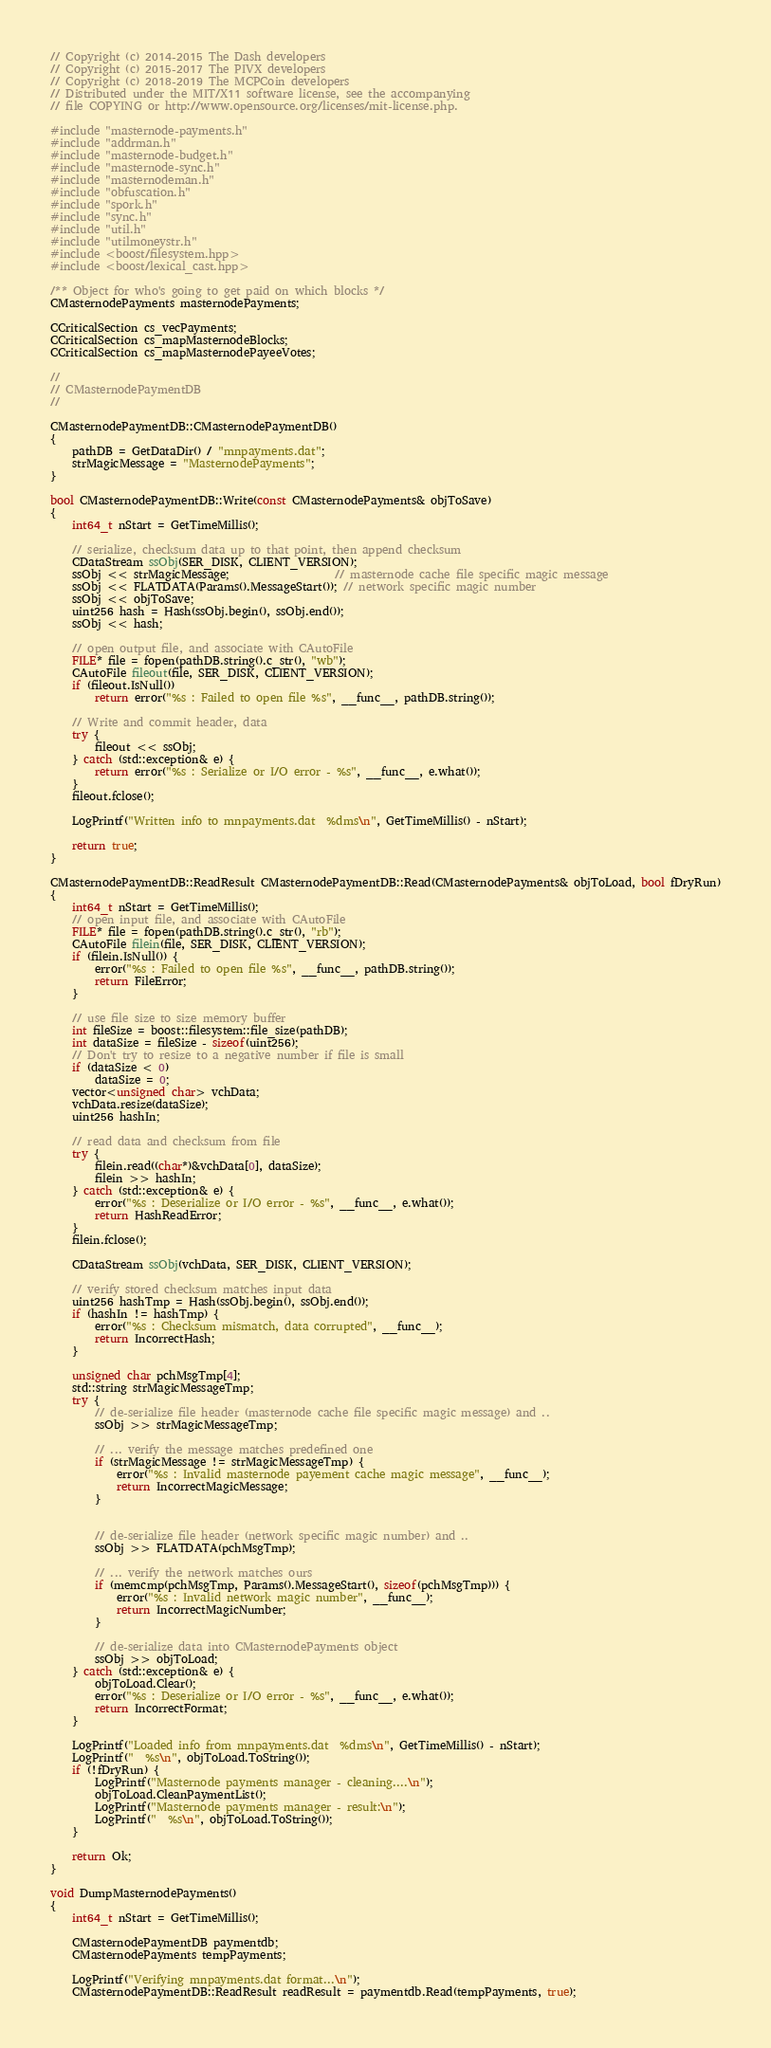<code> <loc_0><loc_0><loc_500><loc_500><_C++_>// Copyright (c) 2014-2015 The Dash developers
// Copyright (c) 2015-2017 The PIVX developers
// Copyright (c) 2018-2019 The MCPCoin developers
// Distributed under the MIT/X11 software license, see the accompanying
// file COPYING or http://www.opensource.org/licenses/mit-license.php.

#include "masternode-payments.h"
#include "addrman.h"
#include "masternode-budget.h"
#include "masternode-sync.h"
#include "masternodeman.h"
#include "obfuscation.h"
#include "spork.h"
#include "sync.h"
#include "util.h"
#include "utilmoneystr.h"
#include <boost/filesystem.hpp>
#include <boost/lexical_cast.hpp>

/** Object for who's going to get paid on which blocks */
CMasternodePayments masternodePayments;

CCriticalSection cs_vecPayments;
CCriticalSection cs_mapMasternodeBlocks;
CCriticalSection cs_mapMasternodePayeeVotes;

//
// CMasternodePaymentDB
//

CMasternodePaymentDB::CMasternodePaymentDB()
{
    pathDB = GetDataDir() / "mnpayments.dat";
    strMagicMessage = "MasternodePayments";
}

bool CMasternodePaymentDB::Write(const CMasternodePayments& objToSave)
{
    int64_t nStart = GetTimeMillis();

    // serialize, checksum data up to that point, then append checksum
    CDataStream ssObj(SER_DISK, CLIENT_VERSION);
    ssObj << strMagicMessage;                   // masternode cache file specific magic message
    ssObj << FLATDATA(Params().MessageStart()); // network specific magic number
    ssObj << objToSave;
    uint256 hash = Hash(ssObj.begin(), ssObj.end());
    ssObj << hash;

    // open output file, and associate with CAutoFile
    FILE* file = fopen(pathDB.string().c_str(), "wb");
    CAutoFile fileout(file, SER_DISK, CLIENT_VERSION);
    if (fileout.IsNull())
        return error("%s : Failed to open file %s", __func__, pathDB.string());

    // Write and commit header, data
    try {
        fileout << ssObj;
    } catch (std::exception& e) {
        return error("%s : Serialize or I/O error - %s", __func__, e.what());
    }
    fileout.fclose();

    LogPrintf("Written info to mnpayments.dat  %dms\n", GetTimeMillis() - nStart);

    return true;
}

CMasternodePaymentDB::ReadResult CMasternodePaymentDB::Read(CMasternodePayments& objToLoad, bool fDryRun)
{
    int64_t nStart = GetTimeMillis();
    // open input file, and associate with CAutoFile
    FILE* file = fopen(pathDB.string().c_str(), "rb");
    CAutoFile filein(file, SER_DISK, CLIENT_VERSION);
    if (filein.IsNull()) {
        error("%s : Failed to open file %s", __func__, pathDB.string());
        return FileError;
    }

    // use file size to size memory buffer
    int fileSize = boost::filesystem::file_size(pathDB);
    int dataSize = fileSize - sizeof(uint256);
    // Don't try to resize to a negative number if file is small
    if (dataSize < 0)
        dataSize = 0;
    vector<unsigned char> vchData;
    vchData.resize(dataSize);
    uint256 hashIn;

    // read data and checksum from file
    try {
        filein.read((char*)&vchData[0], dataSize);
        filein >> hashIn;
    } catch (std::exception& e) {
        error("%s : Deserialize or I/O error - %s", __func__, e.what());
        return HashReadError;
    }
    filein.fclose();

    CDataStream ssObj(vchData, SER_DISK, CLIENT_VERSION);

    // verify stored checksum matches input data
    uint256 hashTmp = Hash(ssObj.begin(), ssObj.end());
    if (hashIn != hashTmp) {
        error("%s : Checksum mismatch, data corrupted", __func__);
        return IncorrectHash;
    }

    unsigned char pchMsgTmp[4];
    std::string strMagicMessageTmp;
    try {
        // de-serialize file header (masternode cache file specific magic message) and ..
        ssObj >> strMagicMessageTmp;

        // ... verify the message matches predefined one
        if (strMagicMessage != strMagicMessageTmp) {
            error("%s : Invalid masternode payement cache magic message", __func__);
            return IncorrectMagicMessage;
        }


        // de-serialize file header (network specific magic number) and ..
        ssObj >> FLATDATA(pchMsgTmp);

        // ... verify the network matches ours
        if (memcmp(pchMsgTmp, Params().MessageStart(), sizeof(pchMsgTmp))) {
            error("%s : Invalid network magic number", __func__);
            return IncorrectMagicNumber;
        }

        // de-serialize data into CMasternodePayments object
        ssObj >> objToLoad;
    } catch (std::exception& e) {
        objToLoad.Clear();
        error("%s : Deserialize or I/O error - %s", __func__, e.what());
        return IncorrectFormat;
    }

    LogPrintf("Loaded info from mnpayments.dat  %dms\n", GetTimeMillis() - nStart);
    LogPrintf("  %s\n", objToLoad.ToString());
    if (!fDryRun) {
        LogPrintf("Masternode payments manager - cleaning....\n");
        objToLoad.CleanPaymentList();
        LogPrintf("Masternode payments manager - result:\n");
        LogPrintf("  %s\n", objToLoad.ToString());
    }

    return Ok;
}

void DumpMasternodePayments()
{
    int64_t nStart = GetTimeMillis();

    CMasternodePaymentDB paymentdb;
    CMasternodePayments tempPayments;

    LogPrintf("Verifying mnpayments.dat format...\n");
    CMasternodePaymentDB::ReadResult readResult = paymentdb.Read(tempPayments, true);</code> 